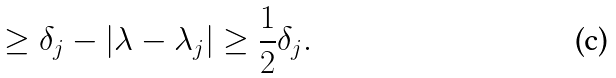Convert formula to latex. <formula><loc_0><loc_0><loc_500><loc_500>\geq \delta _ { j } - | \lambda - \lambda _ { j } | \geq \frac { 1 } { 2 } \delta _ { j } .</formula> 